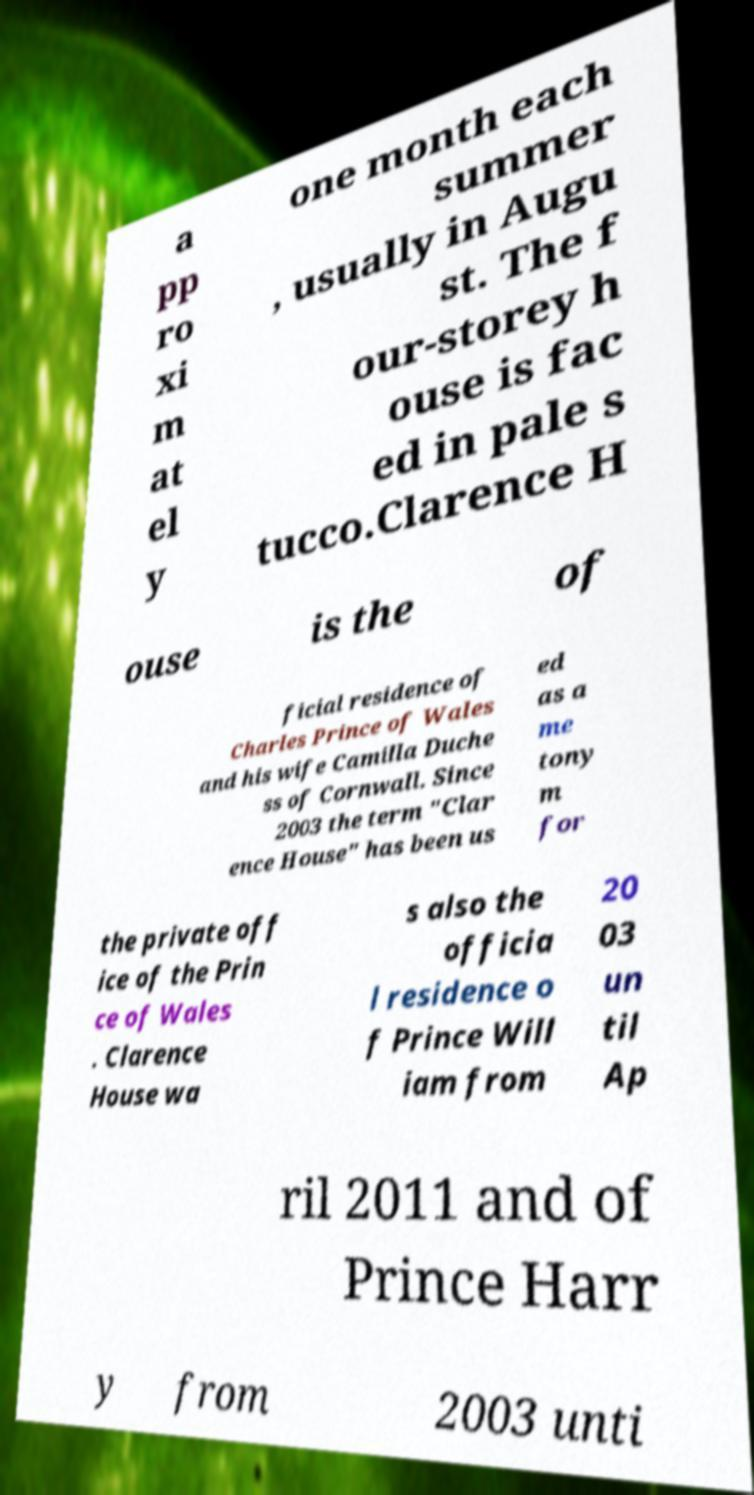Can you accurately transcribe the text from the provided image for me? a pp ro xi m at el y one month each summer , usually in Augu st. The f our-storey h ouse is fac ed in pale s tucco.Clarence H ouse is the of ficial residence of Charles Prince of Wales and his wife Camilla Duche ss of Cornwall. Since 2003 the term "Clar ence House" has been us ed as a me tony m for the private off ice of the Prin ce of Wales . Clarence House wa s also the officia l residence o f Prince Will iam from 20 03 un til Ap ril 2011 and of Prince Harr y from 2003 unti 